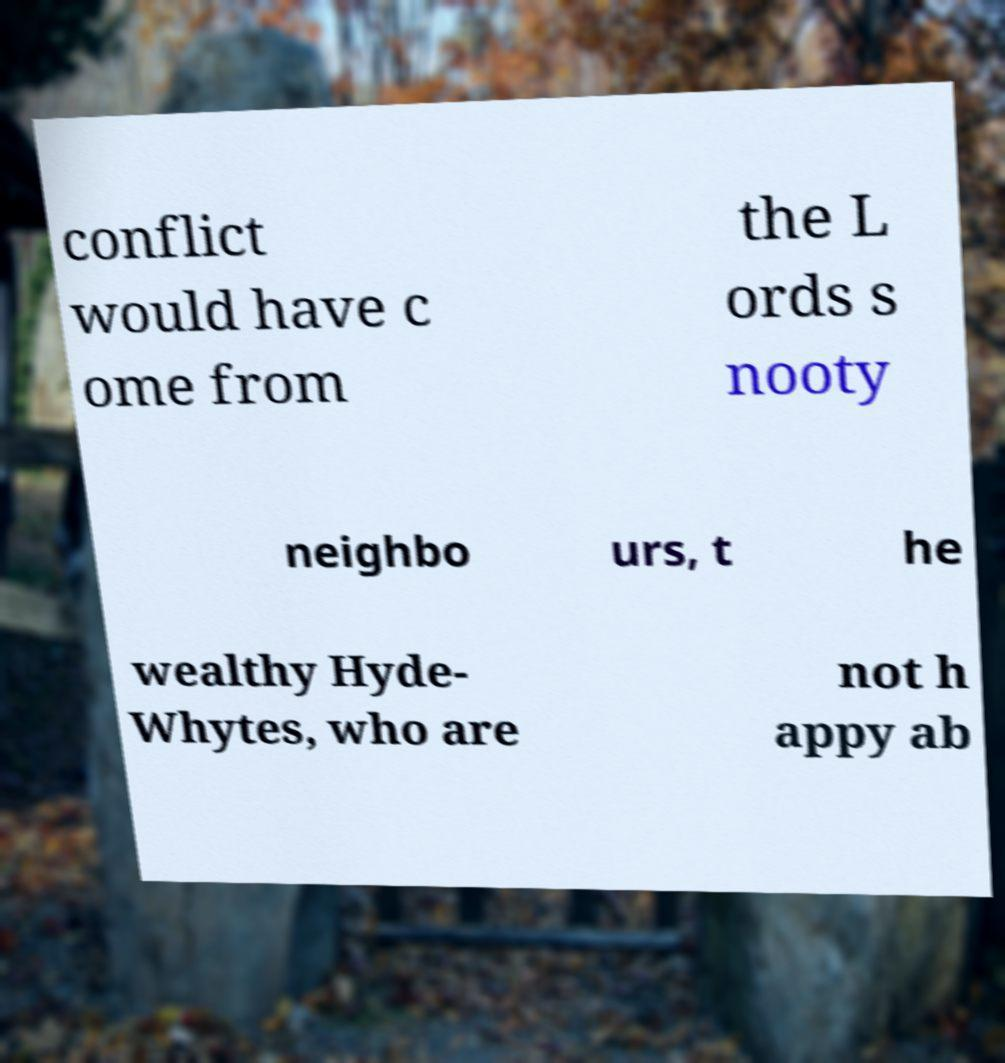Please identify and transcribe the text found in this image. conflict would have c ome from the L ords s nooty neighbo urs, t he wealthy Hyde- Whytes, who are not h appy ab 